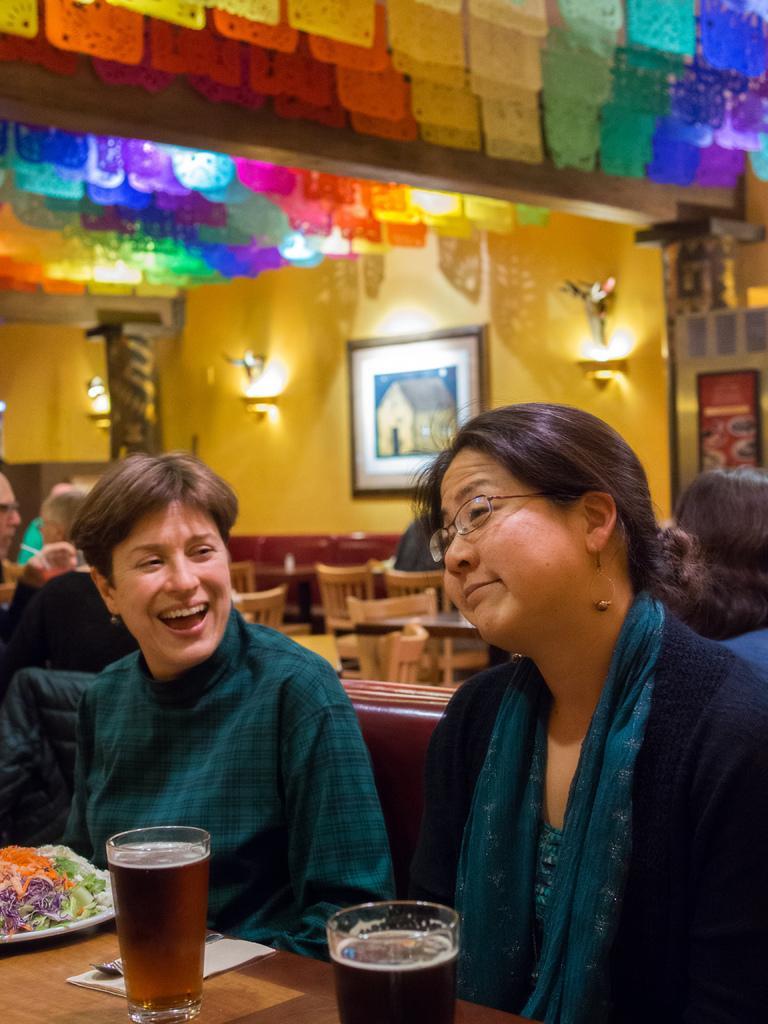Describe this image in one or two sentences. In this picture we can see two woman sitting on chair and they are smiling and in front of them we have glass with drinks in it, plate with some food item, spoons on table and in background we can see wall with frames, lights, chairs, some more persons. 